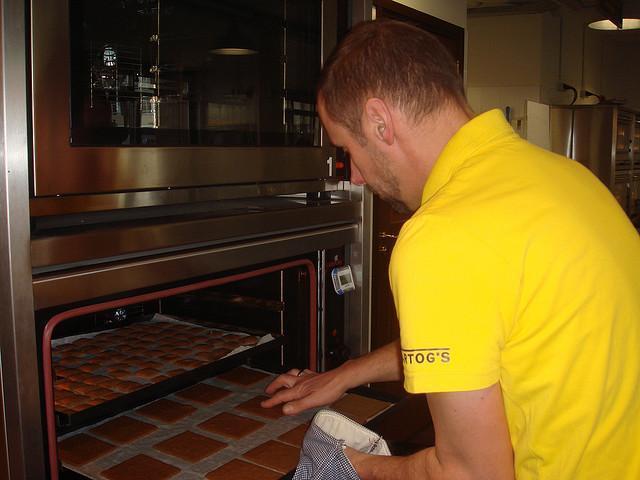Is the caption "The oven is facing the person." a true representation of the image?
Answer yes or no. Yes. Is the given caption "The person is facing the oven." fitting for the image?
Answer yes or no. Yes. 